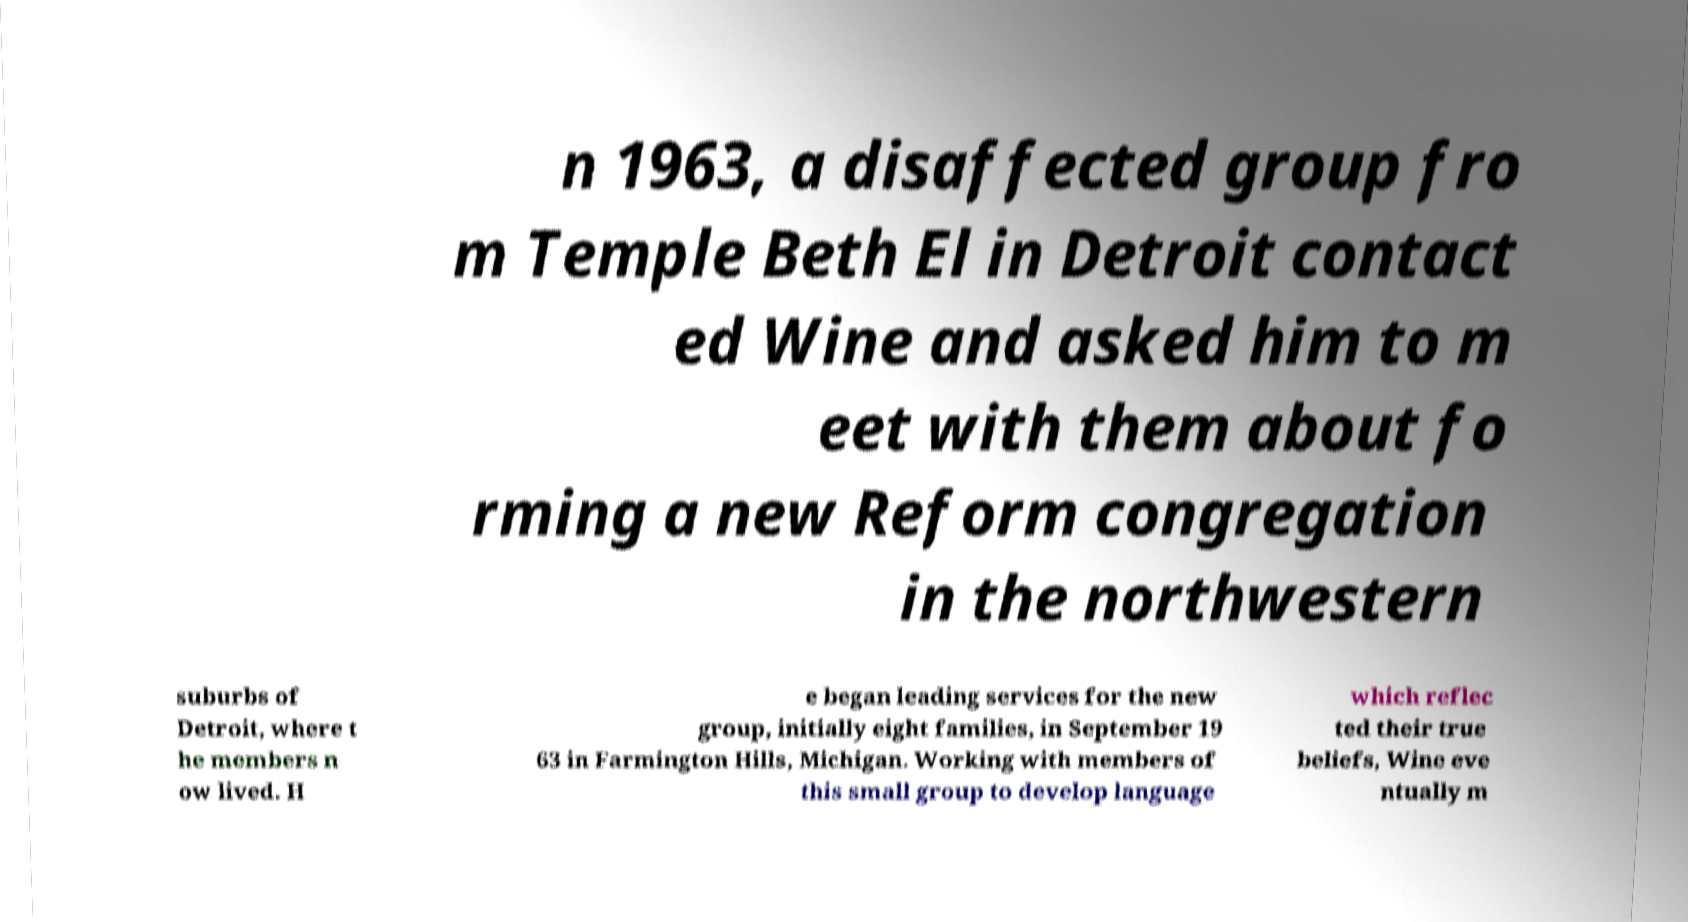Can you accurately transcribe the text from the provided image for me? n 1963, a disaffected group fro m Temple Beth El in Detroit contact ed Wine and asked him to m eet with them about fo rming a new Reform congregation in the northwestern suburbs of Detroit, where t he members n ow lived. H e began leading services for the new group, initially eight families, in September 19 63 in Farmington Hills, Michigan. Working with members of this small group to develop language which reflec ted their true beliefs, Wine eve ntually m 